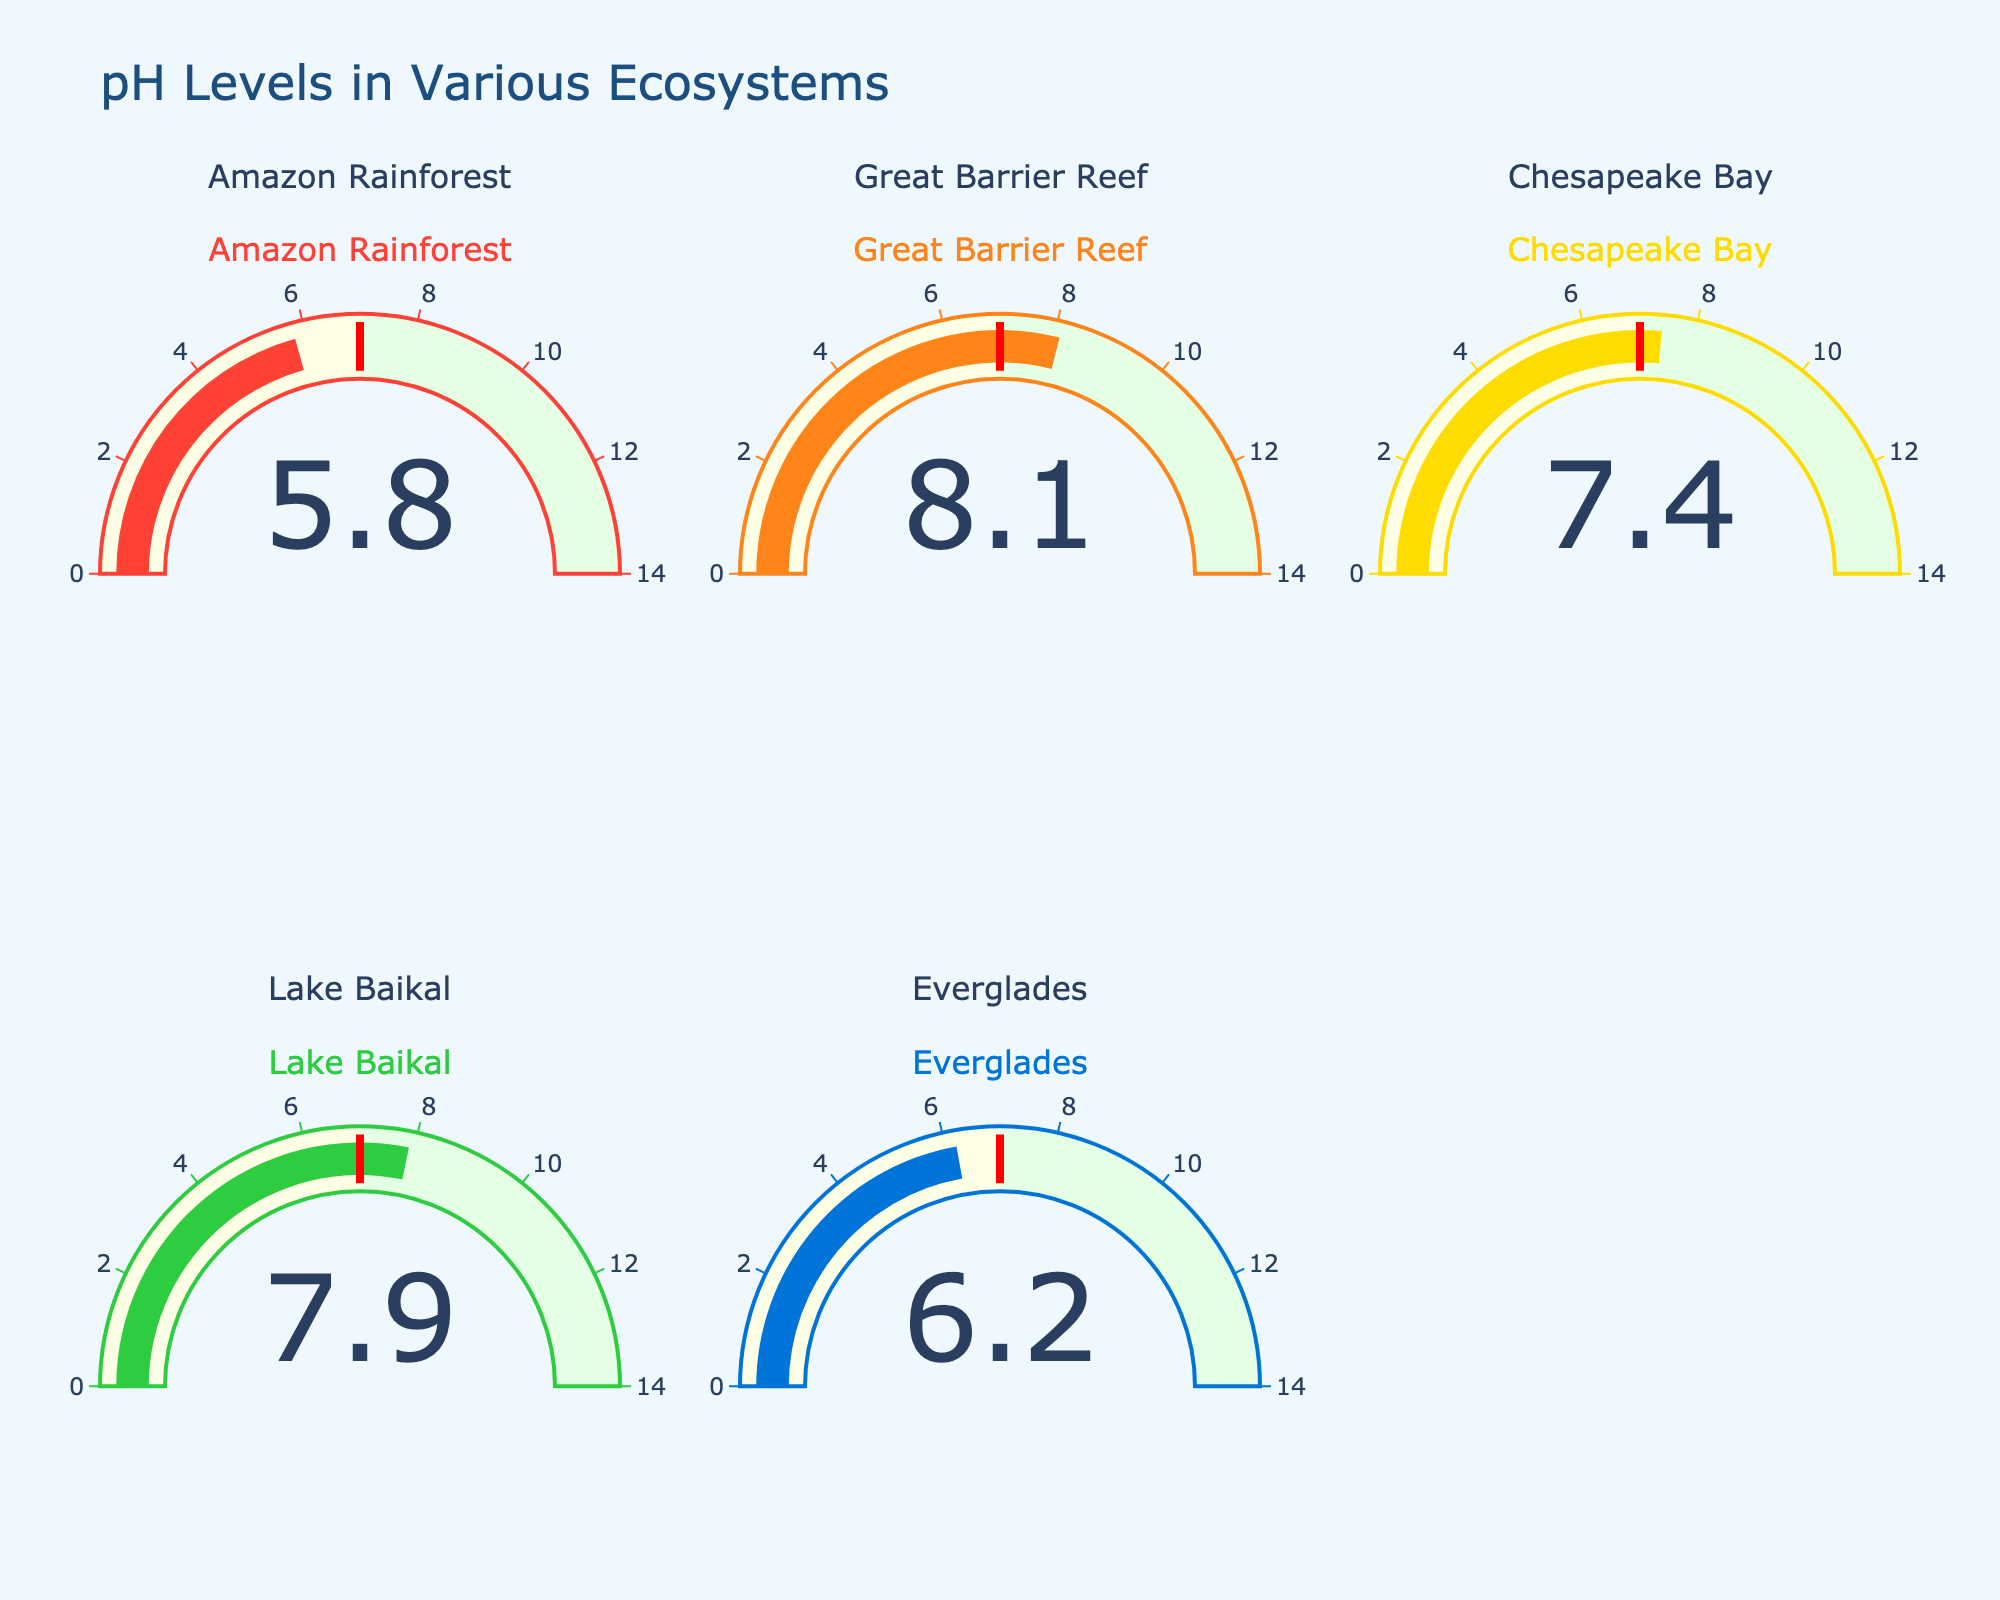Which ecosystem has the highest pH level? The Great Barrier Reef gauge indicates a pH level of 8.1, which is higher than the pH levels of the other ecosystems displayed.
Answer: Great Barrier Reef Which ecosystem has the lowest pH level? The Amazon Rainforest gauge shows a pH level of 5.8, which is the lowest compared to the pH levels of the other ecosystems shown.
Answer: Amazon Rainforest What is the difference in pH levels between Lake Baikal and Chesapeake Bay? The gauge for Lake Baikal shows a pH of 7.9, and the gauge for Chesapeake Bay shows a pH of 7.4. The difference in pH levels is 7.9 - 7.4 = 0.5.
Answer: 0.5 Are any of the ecosystems shown neutral in terms of pH? pH 7 is neutral. None of the gauges indicate a pH of 7; all are either above or below this value.
Answer: No Which ecosystems are above a pH of 7? The gauges for the Great Barrier Reef (8.1), Chesapeake Bay (7.4), and Lake Baikal (7.9) indicate pH levels above 7. The Amazon Rainforest (5.8) and Everglades (6.2) are below 7.
Answer: Great Barrier Reef, Chesapeake Bay, Lake Baikal What is the average pH level of all the ecosystems shown? The pH levels are 5.8, 8.1, 7.4, 7.9, and 6.2. The sum is 5.8 + 8.1 + 7.4 + 7.9 + 6.2 = 35.4. The number of data points is 5. The average pH = 35.4 / 5 = 7.08.
Answer: 7.08 Which ecosystem is closest to a neutral pH? Neutral pH is 7. The Chesapeake Bay has the closest pH level at 7.4, which is nearer to 7 compared to the other ecosystems.
Answer: Chesapeake Bay How many ecosystems have pH values below 7? The gauges for the Amazon Rainforest (5.8) and Everglades (6.2) indicate pH values below 7. There are 2 such ecosystems.
Answer: 2 What is the difference in pH levels between the ecosystem with the highest pH and the ecosystem with the lowest pH? The highest pH is 8.1 (Great Barrier Reef) and the lowest pH is 5.8 (Amazon Rainforest). The difference is 8.1 - 5.8 = 2.3.
Answer: 2.3 